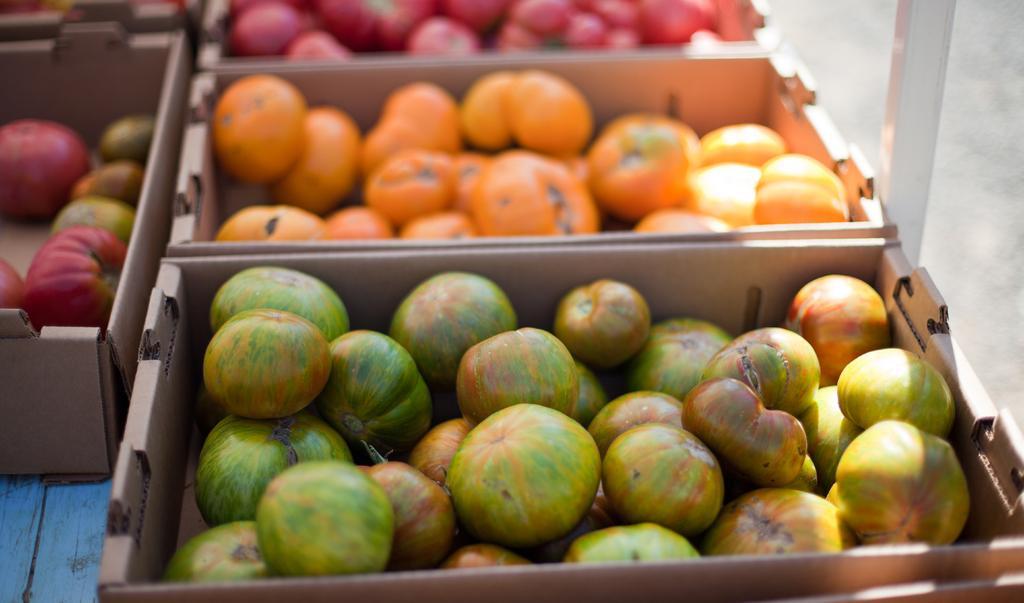Could you give a brief overview of what you see in this image? In the image we can see some baskets, in the baskets there are some fruits. In the top right side of the image there is a pole. 